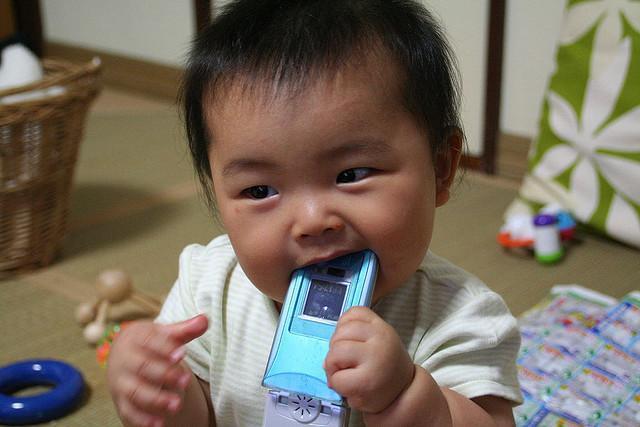How many horse are in this picture?
Give a very brief answer. 0. 